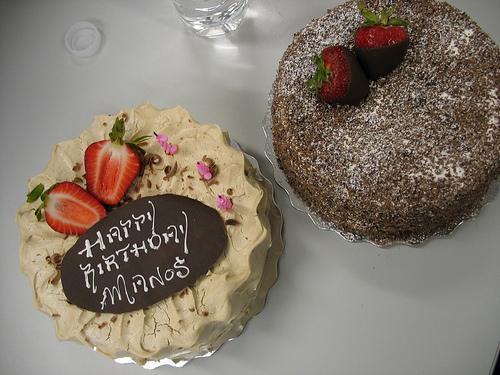How many cakes are visible?
Give a very brief answer. 2. 